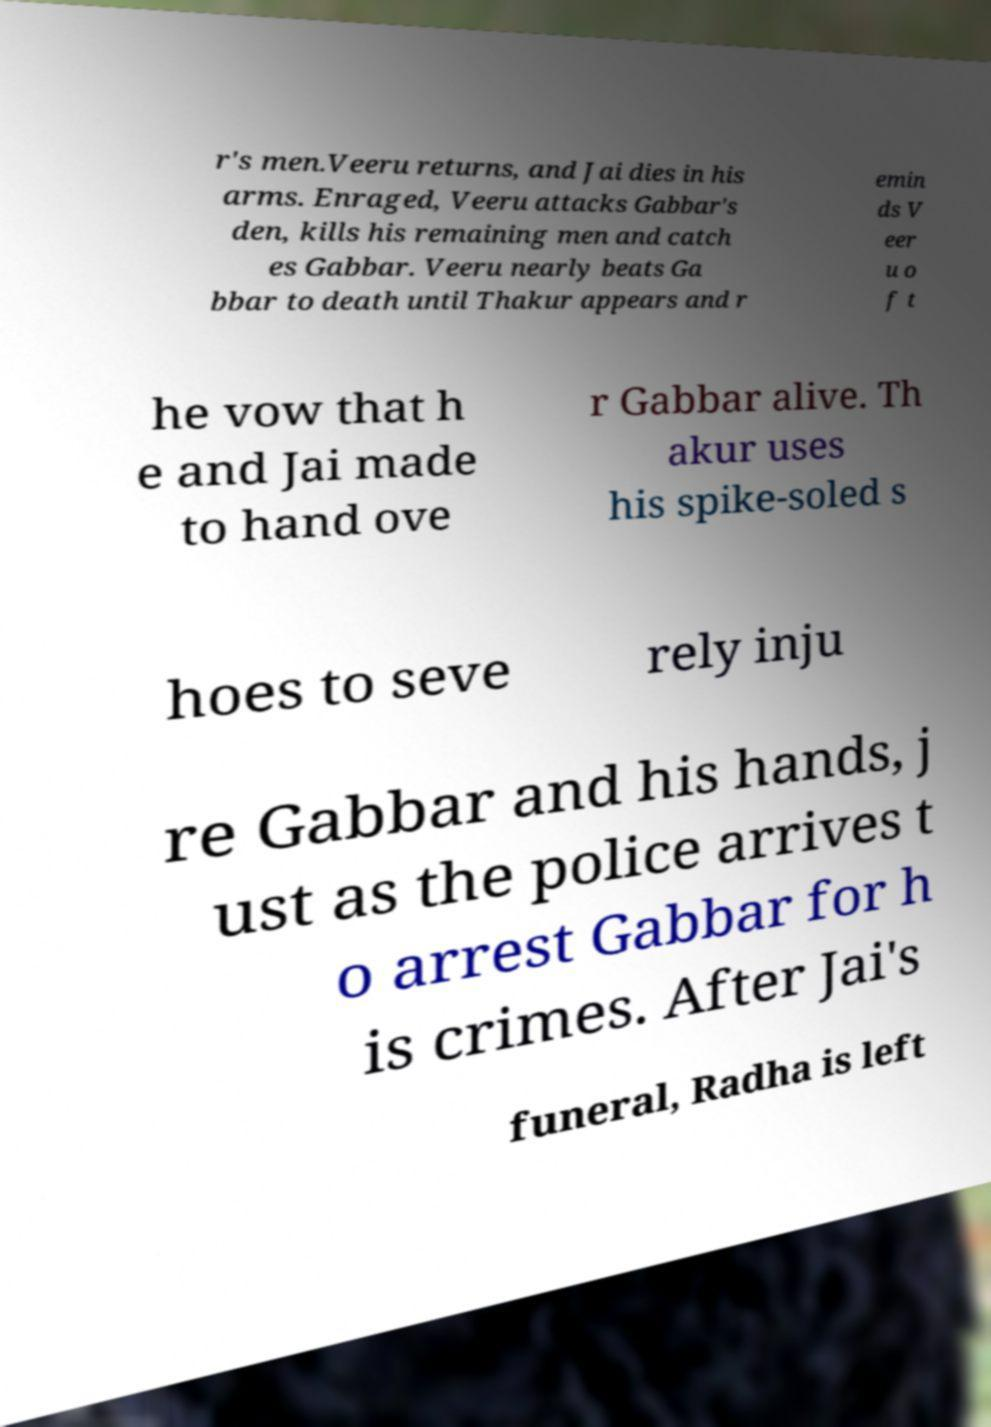Please read and relay the text visible in this image. What does it say? r's men.Veeru returns, and Jai dies in his arms. Enraged, Veeru attacks Gabbar's den, kills his remaining men and catch es Gabbar. Veeru nearly beats Ga bbar to death until Thakur appears and r emin ds V eer u o f t he vow that h e and Jai made to hand ove r Gabbar alive. Th akur uses his spike-soled s hoes to seve rely inju re Gabbar and his hands, j ust as the police arrives t o arrest Gabbar for h is crimes. After Jai's funeral, Radha is left 